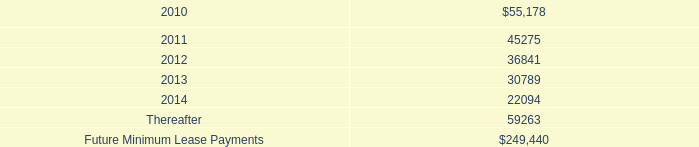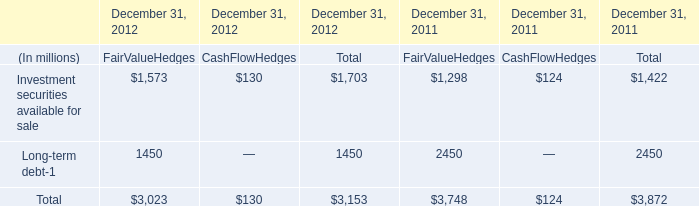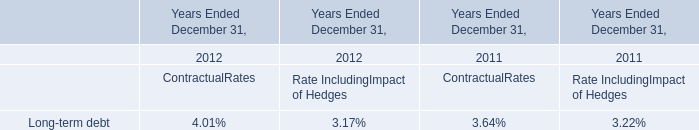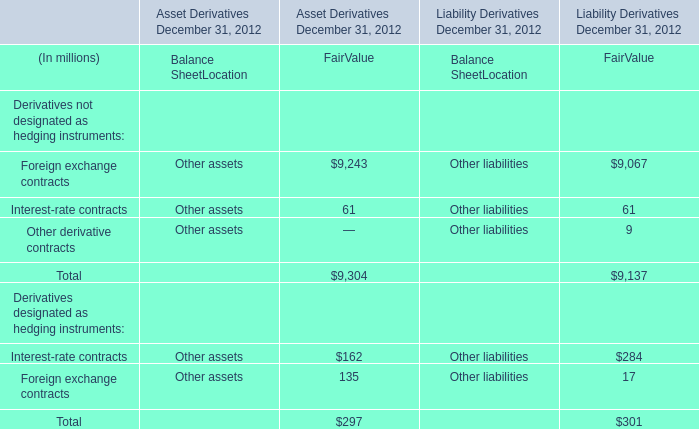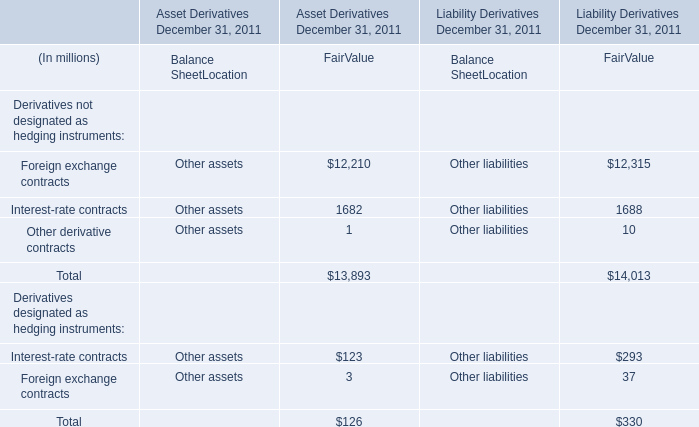What do all FairValueHedges sum up, excluding those negative ones in 2011? (in million) 
Computations: (1298 + 2450)
Answer: 3748.0. 